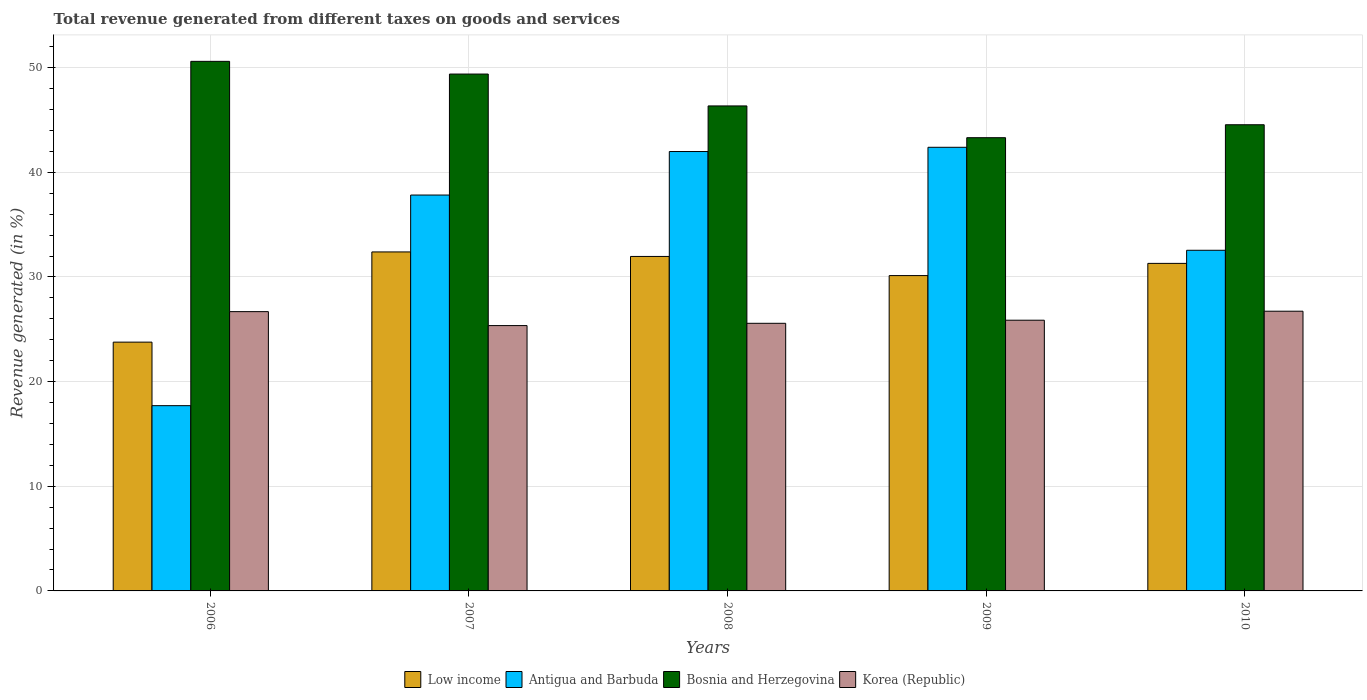How many groups of bars are there?
Your answer should be compact. 5. Are the number of bars per tick equal to the number of legend labels?
Your answer should be compact. Yes. Are the number of bars on each tick of the X-axis equal?
Ensure brevity in your answer.  Yes. What is the total revenue generated in Low income in 2008?
Your answer should be very brief. 31.96. Across all years, what is the maximum total revenue generated in Bosnia and Herzegovina?
Give a very brief answer. 50.6. Across all years, what is the minimum total revenue generated in Korea (Republic)?
Offer a terse response. 25.35. In which year was the total revenue generated in Bosnia and Herzegovina maximum?
Offer a very short reply. 2006. What is the total total revenue generated in Bosnia and Herzegovina in the graph?
Your answer should be compact. 234.18. What is the difference between the total revenue generated in Antigua and Barbuda in 2008 and that in 2009?
Provide a short and direct response. -0.41. What is the difference between the total revenue generated in Antigua and Barbuda in 2007 and the total revenue generated in Korea (Republic) in 2006?
Provide a short and direct response. 11.14. What is the average total revenue generated in Bosnia and Herzegovina per year?
Ensure brevity in your answer.  46.84. In the year 2010, what is the difference between the total revenue generated in Bosnia and Herzegovina and total revenue generated in Korea (Republic)?
Make the answer very short. 17.82. In how many years, is the total revenue generated in Low income greater than 32 %?
Provide a short and direct response. 1. What is the ratio of the total revenue generated in Korea (Republic) in 2007 to that in 2008?
Your answer should be very brief. 0.99. What is the difference between the highest and the second highest total revenue generated in Antigua and Barbuda?
Give a very brief answer. 0.41. What is the difference between the highest and the lowest total revenue generated in Korea (Republic)?
Your response must be concise. 1.37. Is the sum of the total revenue generated in Low income in 2006 and 2009 greater than the maximum total revenue generated in Antigua and Barbuda across all years?
Provide a succinct answer. Yes. What does the 2nd bar from the left in 2006 represents?
Keep it short and to the point. Antigua and Barbuda. How many years are there in the graph?
Offer a very short reply. 5. What is the difference between two consecutive major ticks on the Y-axis?
Give a very brief answer. 10. Does the graph contain any zero values?
Ensure brevity in your answer.  No. Does the graph contain grids?
Your response must be concise. Yes. How many legend labels are there?
Keep it short and to the point. 4. What is the title of the graph?
Make the answer very short. Total revenue generated from different taxes on goods and services. Does "Kosovo" appear as one of the legend labels in the graph?
Offer a terse response. No. What is the label or title of the X-axis?
Provide a succinct answer. Years. What is the label or title of the Y-axis?
Your answer should be very brief. Revenue generated (in %). What is the Revenue generated (in %) in Low income in 2006?
Offer a terse response. 23.77. What is the Revenue generated (in %) in Antigua and Barbuda in 2006?
Offer a very short reply. 17.7. What is the Revenue generated (in %) of Bosnia and Herzegovina in 2006?
Provide a short and direct response. 50.6. What is the Revenue generated (in %) in Korea (Republic) in 2006?
Ensure brevity in your answer.  26.69. What is the Revenue generated (in %) of Low income in 2007?
Your response must be concise. 32.39. What is the Revenue generated (in %) of Antigua and Barbuda in 2007?
Make the answer very short. 37.83. What is the Revenue generated (in %) in Bosnia and Herzegovina in 2007?
Your answer should be very brief. 49.39. What is the Revenue generated (in %) of Korea (Republic) in 2007?
Your response must be concise. 25.35. What is the Revenue generated (in %) in Low income in 2008?
Keep it short and to the point. 31.96. What is the Revenue generated (in %) of Antigua and Barbuda in 2008?
Provide a succinct answer. 41.98. What is the Revenue generated (in %) of Bosnia and Herzegovina in 2008?
Your answer should be compact. 46.34. What is the Revenue generated (in %) of Korea (Republic) in 2008?
Offer a terse response. 25.57. What is the Revenue generated (in %) in Low income in 2009?
Make the answer very short. 30.13. What is the Revenue generated (in %) of Antigua and Barbuda in 2009?
Keep it short and to the point. 42.39. What is the Revenue generated (in %) in Bosnia and Herzegovina in 2009?
Make the answer very short. 43.31. What is the Revenue generated (in %) in Korea (Republic) in 2009?
Give a very brief answer. 25.87. What is the Revenue generated (in %) of Low income in 2010?
Your answer should be very brief. 31.3. What is the Revenue generated (in %) in Antigua and Barbuda in 2010?
Your response must be concise. 32.55. What is the Revenue generated (in %) of Bosnia and Herzegovina in 2010?
Ensure brevity in your answer.  44.54. What is the Revenue generated (in %) of Korea (Republic) in 2010?
Give a very brief answer. 26.73. Across all years, what is the maximum Revenue generated (in %) in Low income?
Provide a short and direct response. 32.39. Across all years, what is the maximum Revenue generated (in %) in Antigua and Barbuda?
Your response must be concise. 42.39. Across all years, what is the maximum Revenue generated (in %) of Bosnia and Herzegovina?
Provide a succinct answer. 50.6. Across all years, what is the maximum Revenue generated (in %) in Korea (Republic)?
Your answer should be compact. 26.73. Across all years, what is the minimum Revenue generated (in %) of Low income?
Offer a terse response. 23.77. Across all years, what is the minimum Revenue generated (in %) in Antigua and Barbuda?
Your answer should be compact. 17.7. Across all years, what is the minimum Revenue generated (in %) in Bosnia and Herzegovina?
Provide a succinct answer. 43.31. Across all years, what is the minimum Revenue generated (in %) of Korea (Republic)?
Your answer should be very brief. 25.35. What is the total Revenue generated (in %) in Low income in the graph?
Make the answer very short. 149.55. What is the total Revenue generated (in %) of Antigua and Barbuda in the graph?
Your answer should be very brief. 172.45. What is the total Revenue generated (in %) of Bosnia and Herzegovina in the graph?
Provide a succinct answer. 234.18. What is the total Revenue generated (in %) in Korea (Republic) in the graph?
Ensure brevity in your answer.  130.2. What is the difference between the Revenue generated (in %) in Low income in 2006 and that in 2007?
Offer a very short reply. -8.62. What is the difference between the Revenue generated (in %) in Antigua and Barbuda in 2006 and that in 2007?
Offer a very short reply. -20.13. What is the difference between the Revenue generated (in %) in Bosnia and Herzegovina in 2006 and that in 2007?
Offer a terse response. 1.21. What is the difference between the Revenue generated (in %) of Korea (Republic) in 2006 and that in 2007?
Your response must be concise. 1.33. What is the difference between the Revenue generated (in %) of Low income in 2006 and that in 2008?
Provide a short and direct response. -8.19. What is the difference between the Revenue generated (in %) in Antigua and Barbuda in 2006 and that in 2008?
Ensure brevity in your answer.  -24.28. What is the difference between the Revenue generated (in %) in Bosnia and Herzegovina in 2006 and that in 2008?
Your answer should be compact. 4.26. What is the difference between the Revenue generated (in %) of Korea (Republic) in 2006 and that in 2008?
Your answer should be very brief. 1.12. What is the difference between the Revenue generated (in %) in Low income in 2006 and that in 2009?
Offer a terse response. -6.36. What is the difference between the Revenue generated (in %) in Antigua and Barbuda in 2006 and that in 2009?
Your answer should be compact. -24.69. What is the difference between the Revenue generated (in %) in Bosnia and Herzegovina in 2006 and that in 2009?
Your answer should be compact. 7.3. What is the difference between the Revenue generated (in %) in Korea (Republic) in 2006 and that in 2009?
Keep it short and to the point. 0.82. What is the difference between the Revenue generated (in %) of Low income in 2006 and that in 2010?
Offer a terse response. -7.53. What is the difference between the Revenue generated (in %) of Antigua and Barbuda in 2006 and that in 2010?
Offer a very short reply. -14.85. What is the difference between the Revenue generated (in %) in Bosnia and Herzegovina in 2006 and that in 2010?
Provide a short and direct response. 6.06. What is the difference between the Revenue generated (in %) in Korea (Republic) in 2006 and that in 2010?
Ensure brevity in your answer.  -0.04. What is the difference between the Revenue generated (in %) of Low income in 2007 and that in 2008?
Your answer should be very brief. 0.43. What is the difference between the Revenue generated (in %) of Antigua and Barbuda in 2007 and that in 2008?
Offer a terse response. -4.16. What is the difference between the Revenue generated (in %) of Bosnia and Herzegovina in 2007 and that in 2008?
Offer a terse response. 3.04. What is the difference between the Revenue generated (in %) in Korea (Republic) in 2007 and that in 2008?
Ensure brevity in your answer.  -0.22. What is the difference between the Revenue generated (in %) of Low income in 2007 and that in 2009?
Provide a short and direct response. 2.26. What is the difference between the Revenue generated (in %) of Antigua and Barbuda in 2007 and that in 2009?
Your answer should be very brief. -4.56. What is the difference between the Revenue generated (in %) of Bosnia and Herzegovina in 2007 and that in 2009?
Make the answer very short. 6.08. What is the difference between the Revenue generated (in %) in Korea (Republic) in 2007 and that in 2009?
Your response must be concise. -0.51. What is the difference between the Revenue generated (in %) of Low income in 2007 and that in 2010?
Provide a succinct answer. 1.09. What is the difference between the Revenue generated (in %) of Antigua and Barbuda in 2007 and that in 2010?
Your response must be concise. 5.28. What is the difference between the Revenue generated (in %) in Bosnia and Herzegovina in 2007 and that in 2010?
Provide a succinct answer. 4.84. What is the difference between the Revenue generated (in %) of Korea (Republic) in 2007 and that in 2010?
Keep it short and to the point. -1.37. What is the difference between the Revenue generated (in %) in Low income in 2008 and that in 2009?
Keep it short and to the point. 1.83. What is the difference between the Revenue generated (in %) in Antigua and Barbuda in 2008 and that in 2009?
Your answer should be compact. -0.41. What is the difference between the Revenue generated (in %) of Bosnia and Herzegovina in 2008 and that in 2009?
Your answer should be compact. 3.04. What is the difference between the Revenue generated (in %) in Korea (Republic) in 2008 and that in 2009?
Provide a short and direct response. -0.3. What is the difference between the Revenue generated (in %) of Low income in 2008 and that in 2010?
Provide a succinct answer. 0.66. What is the difference between the Revenue generated (in %) of Antigua and Barbuda in 2008 and that in 2010?
Ensure brevity in your answer.  9.44. What is the difference between the Revenue generated (in %) in Bosnia and Herzegovina in 2008 and that in 2010?
Keep it short and to the point. 1.8. What is the difference between the Revenue generated (in %) in Korea (Republic) in 2008 and that in 2010?
Give a very brief answer. -1.16. What is the difference between the Revenue generated (in %) of Low income in 2009 and that in 2010?
Ensure brevity in your answer.  -1.17. What is the difference between the Revenue generated (in %) of Antigua and Barbuda in 2009 and that in 2010?
Your answer should be very brief. 9.84. What is the difference between the Revenue generated (in %) in Bosnia and Herzegovina in 2009 and that in 2010?
Your answer should be compact. -1.24. What is the difference between the Revenue generated (in %) of Korea (Republic) in 2009 and that in 2010?
Give a very brief answer. -0.86. What is the difference between the Revenue generated (in %) in Low income in 2006 and the Revenue generated (in %) in Antigua and Barbuda in 2007?
Provide a succinct answer. -14.06. What is the difference between the Revenue generated (in %) of Low income in 2006 and the Revenue generated (in %) of Bosnia and Herzegovina in 2007?
Ensure brevity in your answer.  -25.62. What is the difference between the Revenue generated (in %) of Low income in 2006 and the Revenue generated (in %) of Korea (Republic) in 2007?
Your answer should be compact. -1.58. What is the difference between the Revenue generated (in %) of Antigua and Barbuda in 2006 and the Revenue generated (in %) of Bosnia and Herzegovina in 2007?
Your answer should be very brief. -31.68. What is the difference between the Revenue generated (in %) of Antigua and Barbuda in 2006 and the Revenue generated (in %) of Korea (Republic) in 2007?
Give a very brief answer. -7.65. What is the difference between the Revenue generated (in %) in Bosnia and Herzegovina in 2006 and the Revenue generated (in %) in Korea (Republic) in 2007?
Offer a terse response. 25.25. What is the difference between the Revenue generated (in %) in Low income in 2006 and the Revenue generated (in %) in Antigua and Barbuda in 2008?
Offer a very short reply. -18.21. What is the difference between the Revenue generated (in %) in Low income in 2006 and the Revenue generated (in %) in Bosnia and Herzegovina in 2008?
Offer a very short reply. -22.57. What is the difference between the Revenue generated (in %) in Low income in 2006 and the Revenue generated (in %) in Korea (Republic) in 2008?
Provide a short and direct response. -1.8. What is the difference between the Revenue generated (in %) in Antigua and Barbuda in 2006 and the Revenue generated (in %) in Bosnia and Herzegovina in 2008?
Ensure brevity in your answer.  -28.64. What is the difference between the Revenue generated (in %) of Antigua and Barbuda in 2006 and the Revenue generated (in %) of Korea (Republic) in 2008?
Keep it short and to the point. -7.87. What is the difference between the Revenue generated (in %) in Bosnia and Herzegovina in 2006 and the Revenue generated (in %) in Korea (Republic) in 2008?
Your answer should be very brief. 25.03. What is the difference between the Revenue generated (in %) in Low income in 2006 and the Revenue generated (in %) in Antigua and Barbuda in 2009?
Your answer should be compact. -18.62. What is the difference between the Revenue generated (in %) of Low income in 2006 and the Revenue generated (in %) of Bosnia and Herzegovina in 2009?
Your answer should be very brief. -19.53. What is the difference between the Revenue generated (in %) of Low income in 2006 and the Revenue generated (in %) of Korea (Republic) in 2009?
Ensure brevity in your answer.  -2.1. What is the difference between the Revenue generated (in %) of Antigua and Barbuda in 2006 and the Revenue generated (in %) of Bosnia and Herzegovina in 2009?
Your response must be concise. -25.6. What is the difference between the Revenue generated (in %) in Antigua and Barbuda in 2006 and the Revenue generated (in %) in Korea (Republic) in 2009?
Your response must be concise. -8.16. What is the difference between the Revenue generated (in %) of Bosnia and Herzegovina in 2006 and the Revenue generated (in %) of Korea (Republic) in 2009?
Provide a short and direct response. 24.73. What is the difference between the Revenue generated (in %) in Low income in 2006 and the Revenue generated (in %) in Antigua and Barbuda in 2010?
Offer a terse response. -8.78. What is the difference between the Revenue generated (in %) of Low income in 2006 and the Revenue generated (in %) of Bosnia and Herzegovina in 2010?
Offer a very short reply. -20.77. What is the difference between the Revenue generated (in %) of Low income in 2006 and the Revenue generated (in %) of Korea (Republic) in 2010?
Keep it short and to the point. -2.96. What is the difference between the Revenue generated (in %) in Antigua and Barbuda in 2006 and the Revenue generated (in %) in Bosnia and Herzegovina in 2010?
Offer a very short reply. -26.84. What is the difference between the Revenue generated (in %) of Antigua and Barbuda in 2006 and the Revenue generated (in %) of Korea (Republic) in 2010?
Provide a short and direct response. -9.03. What is the difference between the Revenue generated (in %) in Bosnia and Herzegovina in 2006 and the Revenue generated (in %) in Korea (Republic) in 2010?
Keep it short and to the point. 23.87. What is the difference between the Revenue generated (in %) in Low income in 2007 and the Revenue generated (in %) in Antigua and Barbuda in 2008?
Your answer should be compact. -9.59. What is the difference between the Revenue generated (in %) of Low income in 2007 and the Revenue generated (in %) of Bosnia and Herzegovina in 2008?
Offer a very short reply. -13.95. What is the difference between the Revenue generated (in %) in Low income in 2007 and the Revenue generated (in %) in Korea (Republic) in 2008?
Your answer should be compact. 6.82. What is the difference between the Revenue generated (in %) in Antigua and Barbuda in 2007 and the Revenue generated (in %) in Bosnia and Herzegovina in 2008?
Your answer should be compact. -8.51. What is the difference between the Revenue generated (in %) of Antigua and Barbuda in 2007 and the Revenue generated (in %) of Korea (Republic) in 2008?
Offer a terse response. 12.26. What is the difference between the Revenue generated (in %) in Bosnia and Herzegovina in 2007 and the Revenue generated (in %) in Korea (Republic) in 2008?
Keep it short and to the point. 23.82. What is the difference between the Revenue generated (in %) of Low income in 2007 and the Revenue generated (in %) of Antigua and Barbuda in 2009?
Keep it short and to the point. -10. What is the difference between the Revenue generated (in %) of Low income in 2007 and the Revenue generated (in %) of Bosnia and Herzegovina in 2009?
Your answer should be very brief. -10.91. What is the difference between the Revenue generated (in %) of Low income in 2007 and the Revenue generated (in %) of Korea (Republic) in 2009?
Provide a short and direct response. 6.52. What is the difference between the Revenue generated (in %) in Antigua and Barbuda in 2007 and the Revenue generated (in %) in Bosnia and Herzegovina in 2009?
Provide a succinct answer. -5.48. What is the difference between the Revenue generated (in %) in Antigua and Barbuda in 2007 and the Revenue generated (in %) in Korea (Republic) in 2009?
Offer a terse response. 11.96. What is the difference between the Revenue generated (in %) of Bosnia and Herzegovina in 2007 and the Revenue generated (in %) of Korea (Republic) in 2009?
Make the answer very short. 23.52. What is the difference between the Revenue generated (in %) of Low income in 2007 and the Revenue generated (in %) of Antigua and Barbuda in 2010?
Make the answer very short. -0.16. What is the difference between the Revenue generated (in %) of Low income in 2007 and the Revenue generated (in %) of Bosnia and Herzegovina in 2010?
Make the answer very short. -12.15. What is the difference between the Revenue generated (in %) in Low income in 2007 and the Revenue generated (in %) in Korea (Republic) in 2010?
Provide a succinct answer. 5.66. What is the difference between the Revenue generated (in %) of Antigua and Barbuda in 2007 and the Revenue generated (in %) of Bosnia and Herzegovina in 2010?
Your answer should be compact. -6.72. What is the difference between the Revenue generated (in %) in Antigua and Barbuda in 2007 and the Revenue generated (in %) in Korea (Republic) in 2010?
Your response must be concise. 11.1. What is the difference between the Revenue generated (in %) of Bosnia and Herzegovina in 2007 and the Revenue generated (in %) of Korea (Republic) in 2010?
Offer a terse response. 22.66. What is the difference between the Revenue generated (in %) in Low income in 2008 and the Revenue generated (in %) in Antigua and Barbuda in 2009?
Your response must be concise. -10.43. What is the difference between the Revenue generated (in %) in Low income in 2008 and the Revenue generated (in %) in Bosnia and Herzegovina in 2009?
Provide a succinct answer. -11.35. What is the difference between the Revenue generated (in %) of Low income in 2008 and the Revenue generated (in %) of Korea (Republic) in 2009?
Make the answer very short. 6.09. What is the difference between the Revenue generated (in %) of Antigua and Barbuda in 2008 and the Revenue generated (in %) of Bosnia and Herzegovina in 2009?
Keep it short and to the point. -1.32. What is the difference between the Revenue generated (in %) of Antigua and Barbuda in 2008 and the Revenue generated (in %) of Korea (Republic) in 2009?
Provide a short and direct response. 16.12. What is the difference between the Revenue generated (in %) in Bosnia and Herzegovina in 2008 and the Revenue generated (in %) in Korea (Republic) in 2009?
Give a very brief answer. 20.48. What is the difference between the Revenue generated (in %) in Low income in 2008 and the Revenue generated (in %) in Antigua and Barbuda in 2010?
Offer a very short reply. -0.59. What is the difference between the Revenue generated (in %) of Low income in 2008 and the Revenue generated (in %) of Bosnia and Herzegovina in 2010?
Offer a terse response. -12.58. What is the difference between the Revenue generated (in %) in Low income in 2008 and the Revenue generated (in %) in Korea (Republic) in 2010?
Provide a succinct answer. 5.23. What is the difference between the Revenue generated (in %) of Antigua and Barbuda in 2008 and the Revenue generated (in %) of Bosnia and Herzegovina in 2010?
Your response must be concise. -2.56. What is the difference between the Revenue generated (in %) of Antigua and Barbuda in 2008 and the Revenue generated (in %) of Korea (Republic) in 2010?
Ensure brevity in your answer.  15.26. What is the difference between the Revenue generated (in %) in Bosnia and Herzegovina in 2008 and the Revenue generated (in %) in Korea (Republic) in 2010?
Keep it short and to the point. 19.61. What is the difference between the Revenue generated (in %) in Low income in 2009 and the Revenue generated (in %) in Antigua and Barbuda in 2010?
Your answer should be very brief. -2.42. What is the difference between the Revenue generated (in %) in Low income in 2009 and the Revenue generated (in %) in Bosnia and Herzegovina in 2010?
Your answer should be very brief. -14.41. What is the difference between the Revenue generated (in %) of Low income in 2009 and the Revenue generated (in %) of Korea (Republic) in 2010?
Ensure brevity in your answer.  3.4. What is the difference between the Revenue generated (in %) of Antigua and Barbuda in 2009 and the Revenue generated (in %) of Bosnia and Herzegovina in 2010?
Make the answer very short. -2.15. What is the difference between the Revenue generated (in %) in Antigua and Barbuda in 2009 and the Revenue generated (in %) in Korea (Republic) in 2010?
Provide a succinct answer. 15.66. What is the difference between the Revenue generated (in %) of Bosnia and Herzegovina in 2009 and the Revenue generated (in %) of Korea (Republic) in 2010?
Ensure brevity in your answer.  16.58. What is the average Revenue generated (in %) in Low income per year?
Your answer should be very brief. 29.91. What is the average Revenue generated (in %) in Antigua and Barbuda per year?
Make the answer very short. 34.49. What is the average Revenue generated (in %) of Bosnia and Herzegovina per year?
Your response must be concise. 46.84. What is the average Revenue generated (in %) in Korea (Republic) per year?
Give a very brief answer. 26.04. In the year 2006, what is the difference between the Revenue generated (in %) in Low income and Revenue generated (in %) in Antigua and Barbuda?
Provide a short and direct response. 6.07. In the year 2006, what is the difference between the Revenue generated (in %) of Low income and Revenue generated (in %) of Bosnia and Herzegovina?
Provide a short and direct response. -26.83. In the year 2006, what is the difference between the Revenue generated (in %) of Low income and Revenue generated (in %) of Korea (Republic)?
Provide a short and direct response. -2.91. In the year 2006, what is the difference between the Revenue generated (in %) in Antigua and Barbuda and Revenue generated (in %) in Bosnia and Herzegovina?
Your answer should be very brief. -32.9. In the year 2006, what is the difference between the Revenue generated (in %) of Antigua and Barbuda and Revenue generated (in %) of Korea (Republic)?
Your answer should be compact. -8.98. In the year 2006, what is the difference between the Revenue generated (in %) of Bosnia and Herzegovina and Revenue generated (in %) of Korea (Republic)?
Provide a succinct answer. 23.91. In the year 2007, what is the difference between the Revenue generated (in %) in Low income and Revenue generated (in %) in Antigua and Barbuda?
Ensure brevity in your answer.  -5.44. In the year 2007, what is the difference between the Revenue generated (in %) of Low income and Revenue generated (in %) of Bosnia and Herzegovina?
Ensure brevity in your answer.  -17. In the year 2007, what is the difference between the Revenue generated (in %) of Low income and Revenue generated (in %) of Korea (Republic)?
Your answer should be compact. 7.04. In the year 2007, what is the difference between the Revenue generated (in %) of Antigua and Barbuda and Revenue generated (in %) of Bosnia and Herzegovina?
Ensure brevity in your answer.  -11.56. In the year 2007, what is the difference between the Revenue generated (in %) in Antigua and Barbuda and Revenue generated (in %) in Korea (Republic)?
Keep it short and to the point. 12.47. In the year 2007, what is the difference between the Revenue generated (in %) of Bosnia and Herzegovina and Revenue generated (in %) of Korea (Republic)?
Give a very brief answer. 24.03. In the year 2008, what is the difference between the Revenue generated (in %) in Low income and Revenue generated (in %) in Antigua and Barbuda?
Offer a terse response. -10.03. In the year 2008, what is the difference between the Revenue generated (in %) in Low income and Revenue generated (in %) in Bosnia and Herzegovina?
Your answer should be very brief. -14.38. In the year 2008, what is the difference between the Revenue generated (in %) in Low income and Revenue generated (in %) in Korea (Republic)?
Give a very brief answer. 6.39. In the year 2008, what is the difference between the Revenue generated (in %) of Antigua and Barbuda and Revenue generated (in %) of Bosnia and Herzegovina?
Your answer should be very brief. -4.36. In the year 2008, what is the difference between the Revenue generated (in %) in Antigua and Barbuda and Revenue generated (in %) in Korea (Republic)?
Ensure brevity in your answer.  16.41. In the year 2008, what is the difference between the Revenue generated (in %) in Bosnia and Herzegovina and Revenue generated (in %) in Korea (Republic)?
Offer a very short reply. 20.77. In the year 2009, what is the difference between the Revenue generated (in %) in Low income and Revenue generated (in %) in Antigua and Barbuda?
Keep it short and to the point. -12.26. In the year 2009, what is the difference between the Revenue generated (in %) in Low income and Revenue generated (in %) in Bosnia and Herzegovina?
Your response must be concise. -13.17. In the year 2009, what is the difference between the Revenue generated (in %) of Low income and Revenue generated (in %) of Korea (Republic)?
Give a very brief answer. 4.26. In the year 2009, what is the difference between the Revenue generated (in %) of Antigua and Barbuda and Revenue generated (in %) of Bosnia and Herzegovina?
Your answer should be very brief. -0.92. In the year 2009, what is the difference between the Revenue generated (in %) of Antigua and Barbuda and Revenue generated (in %) of Korea (Republic)?
Your answer should be compact. 16.52. In the year 2009, what is the difference between the Revenue generated (in %) of Bosnia and Herzegovina and Revenue generated (in %) of Korea (Republic)?
Provide a short and direct response. 17.44. In the year 2010, what is the difference between the Revenue generated (in %) of Low income and Revenue generated (in %) of Antigua and Barbuda?
Ensure brevity in your answer.  -1.25. In the year 2010, what is the difference between the Revenue generated (in %) of Low income and Revenue generated (in %) of Bosnia and Herzegovina?
Ensure brevity in your answer.  -13.25. In the year 2010, what is the difference between the Revenue generated (in %) in Low income and Revenue generated (in %) in Korea (Republic)?
Give a very brief answer. 4.57. In the year 2010, what is the difference between the Revenue generated (in %) in Antigua and Barbuda and Revenue generated (in %) in Bosnia and Herzegovina?
Keep it short and to the point. -11.99. In the year 2010, what is the difference between the Revenue generated (in %) of Antigua and Barbuda and Revenue generated (in %) of Korea (Republic)?
Keep it short and to the point. 5.82. In the year 2010, what is the difference between the Revenue generated (in %) in Bosnia and Herzegovina and Revenue generated (in %) in Korea (Republic)?
Provide a succinct answer. 17.82. What is the ratio of the Revenue generated (in %) of Low income in 2006 to that in 2007?
Your answer should be very brief. 0.73. What is the ratio of the Revenue generated (in %) of Antigua and Barbuda in 2006 to that in 2007?
Ensure brevity in your answer.  0.47. What is the ratio of the Revenue generated (in %) of Bosnia and Herzegovina in 2006 to that in 2007?
Your answer should be very brief. 1.02. What is the ratio of the Revenue generated (in %) in Korea (Republic) in 2006 to that in 2007?
Your answer should be very brief. 1.05. What is the ratio of the Revenue generated (in %) of Low income in 2006 to that in 2008?
Offer a very short reply. 0.74. What is the ratio of the Revenue generated (in %) in Antigua and Barbuda in 2006 to that in 2008?
Ensure brevity in your answer.  0.42. What is the ratio of the Revenue generated (in %) of Bosnia and Herzegovina in 2006 to that in 2008?
Provide a succinct answer. 1.09. What is the ratio of the Revenue generated (in %) in Korea (Republic) in 2006 to that in 2008?
Offer a terse response. 1.04. What is the ratio of the Revenue generated (in %) in Low income in 2006 to that in 2009?
Make the answer very short. 0.79. What is the ratio of the Revenue generated (in %) in Antigua and Barbuda in 2006 to that in 2009?
Your answer should be very brief. 0.42. What is the ratio of the Revenue generated (in %) of Bosnia and Herzegovina in 2006 to that in 2009?
Keep it short and to the point. 1.17. What is the ratio of the Revenue generated (in %) of Korea (Republic) in 2006 to that in 2009?
Provide a short and direct response. 1.03. What is the ratio of the Revenue generated (in %) of Low income in 2006 to that in 2010?
Keep it short and to the point. 0.76. What is the ratio of the Revenue generated (in %) of Antigua and Barbuda in 2006 to that in 2010?
Make the answer very short. 0.54. What is the ratio of the Revenue generated (in %) in Bosnia and Herzegovina in 2006 to that in 2010?
Your answer should be very brief. 1.14. What is the ratio of the Revenue generated (in %) of Korea (Republic) in 2006 to that in 2010?
Offer a terse response. 1. What is the ratio of the Revenue generated (in %) of Low income in 2007 to that in 2008?
Provide a short and direct response. 1.01. What is the ratio of the Revenue generated (in %) of Antigua and Barbuda in 2007 to that in 2008?
Provide a succinct answer. 0.9. What is the ratio of the Revenue generated (in %) of Bosnia and Herzegovina in 2007 to that in 2008?
Ensure brevity in your answer.  1.07. What is the ratio of the Revenue generated (in %) in Korea (Republic) in 2007 to that in 2008?
Make the answer very short. 0.99. What is the ratio of the Revenue generated (in %) of Low income in 2007 to that in 2009?
Keep it short and to the point. 1.07. What is the ratio of the Revenue generated (in %) of Antigua and Barbuda in 2007 to that in 2009?
Offer a terse response. 0.89. What is the ratio of the Revenue generated (in %) of Bosnia and Herzegovina in 2007 to that in 2009?
Keep it short and to the point. 1.14. What is the ratio of the Revenue generated (in %) in Korea (Republic) in 2007 to that in 2009?
Make the answer very short. 0.98. What is the ratio of the Revenue generated (in %) in Low income in 2007 to that in 2010?
Your answer should be very brief. 1.03. What is the ratio of the Revenue generated (in %) in Antigua and Barbuda in 2007 to that in 2010?
Provide a succinct answer. 1.16. What is the ratio of the Revenue generated (in %) in Bosnia and Herzegovina in 2007 to that in 2010?
Ensure brevity in your answer.  1.11. What is the ratio of the Revenue generated (in %) of Korea (Republic) in 2007 to that in 2010?
Provide a short and direct response. 0.95. What is the ratio of the Revenue generated (in %) of Low income in 2008 to that in 2009?
Ensure brevity in your answer.  1.06. What is the ratio of the Revenue generated (in %) in Antigua and Barbuda in 2008 to that in 2009?
Offer a very short reply. 0.99. What is the ratio of the Revenue generated (in %) of Bosnia and Herzegovina in 2008 to that in 2009?
Keep it short and to the point. 1.07. What is the ratio of the Revenue generated (in %) of Korea (Republic) in 2008 to that in 2009?
Your answer should be very brief. 0.99. What is the ratio of the Revenue generated (in %) in Low income in 2008 to that in 2010?
Provide a short and direct response. 1.02. What is the ratio of the Revenue generated (in %) in Antigua and Barbuda in 2008 to that in 2010?
Provide a short and direct response. 1.29. What is the ratio of the Revenue generated (in %) of Bosnia and Herzegovina in 2008 to that in 2010?
Your answer should be very brief. 1.04. What is the ratio of the Revenue generated (in %) of Korea (Republic) in 2008 to that in 2010?
Your response must be concise. 0.96. What is the ratio of the Revenue generated (in %) of Low income in 2009 to that in 2010?
Give a very brief answer. 0.96. What is the ratio of the Revenue generated (in %) of Antigua and Barbuda in 2009 to that in 2010?
Offer a terse response. 1.3. What is the ratio of the Revenue generated (in %) of Bosnia and Herzegovina in 2009 to that in 2010?
Make the answer very short. 0.97. What is the ratio of the Revenue generated (in %) of Korea (Republic) in 2009 to that in 2010?
Ensure brevity in your answer.  0.97. What is the difference between the highest and the second highest Revenue generated (in %) of Low income?
Ensure brevity in your answer.  0.43. What is the difference between the highest and the second highest Revenue generated (in %) in Antigua and Barbuda?
Make the answer very short. 0.41. What is the difference between the highest and the second highest Revenue generated (in %) in Bosnia and Herzegovina?
Provide a succinct answer. 1.21. What is the difference between the highest and the second highest Revenue generated (in %) in Korea (Republic)?
Your response must be concise. 0.04. What is the difference between the highest and the lowest Revenue generated (in %) of Low income?
Provide a short and direct response. 8.62. What is the difference between the highest and the lowest Revenue generated (in %) in Antigua and Barbuda?
Ensure brevity in your answer.  24.69. What is the difference between the highest and the lowest Revenue generated (in %) in Bosnia and Herzegovina?
Your answer should be very brief. 7.3. What is the difference between the highest and the lowest Revenue generated (in %) of Korea (Republic)?
Ensure brevity in your answer.  1.37. 